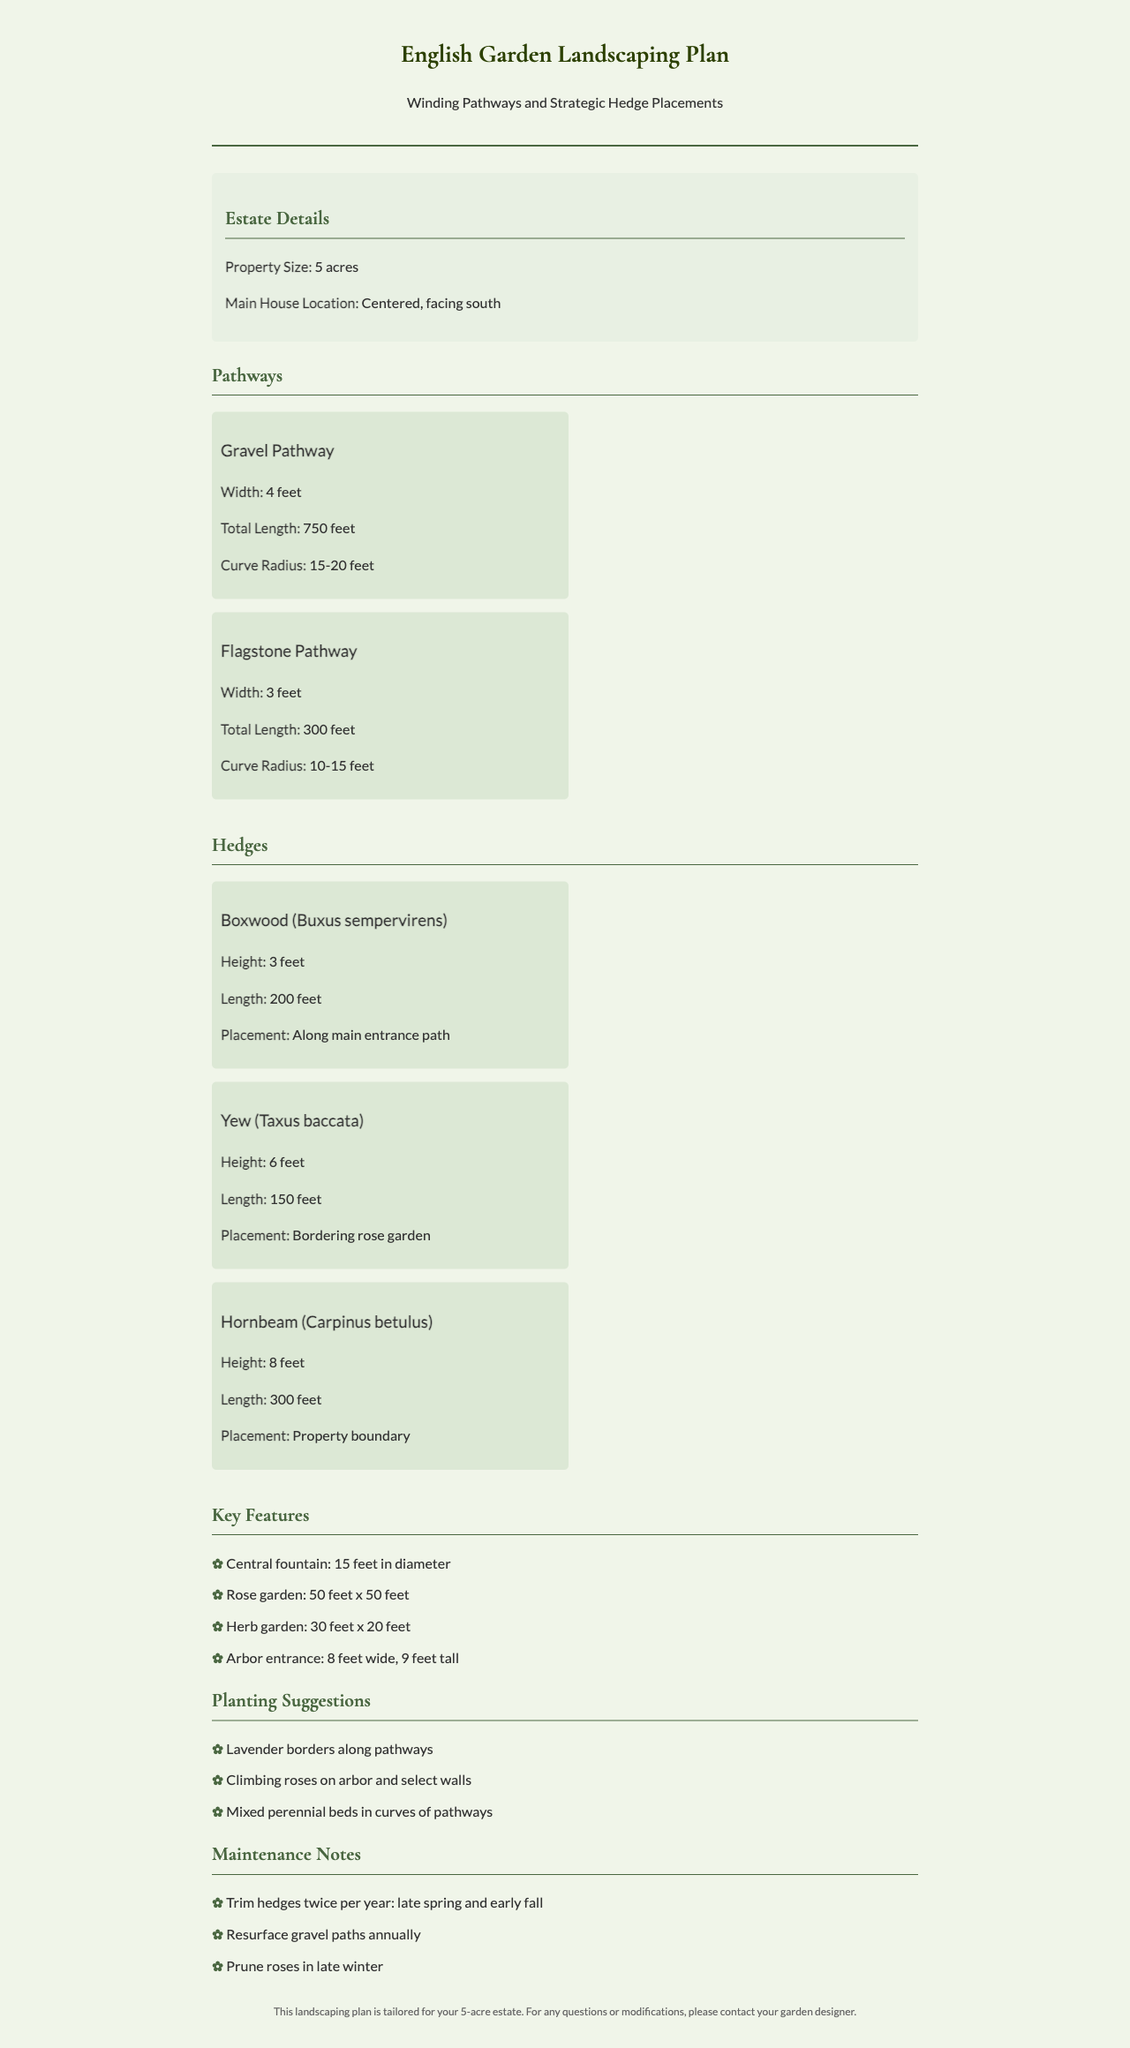What is the total length of the Gravel Pathway? The total length of the Gravel Pathway is mentioned in the document as 750 feet.
Answer: 750 feet What type of hedge is 6 feet tall? The Yew (Taxus baccata) is specifically mentioned as having a height of 6 feet.
Answer: Yew (Taxus baccata) What is the height of the Boxwood hedge? The document specifies that the Boxwood hedge has a height of 3 feet.
Answer: 3 feet What feature is located at the center of the garden? The document identifies a central fountain with a diameter of 15 feet as a key feature.
Answer: Central fountain What is the width of the Arbor entrance? The width of the Arbor entrance is stated to be 8 feet.
Answer: 8 feet How many feet long is the Hornbeam hedge? According to the document, the Hornbeam hedge has a length of 300 feet.
Answer: 300 feet What is the area size of the Rose garden? The area of the Rose garden is given as 50 feet x 50 feet, which indicates its dimensions.
Answer: 50 feet x 50 feet How often should the hedges be trimmed? The document notes that hedges should be trimmed twice per year.
Answer: Twice per year 